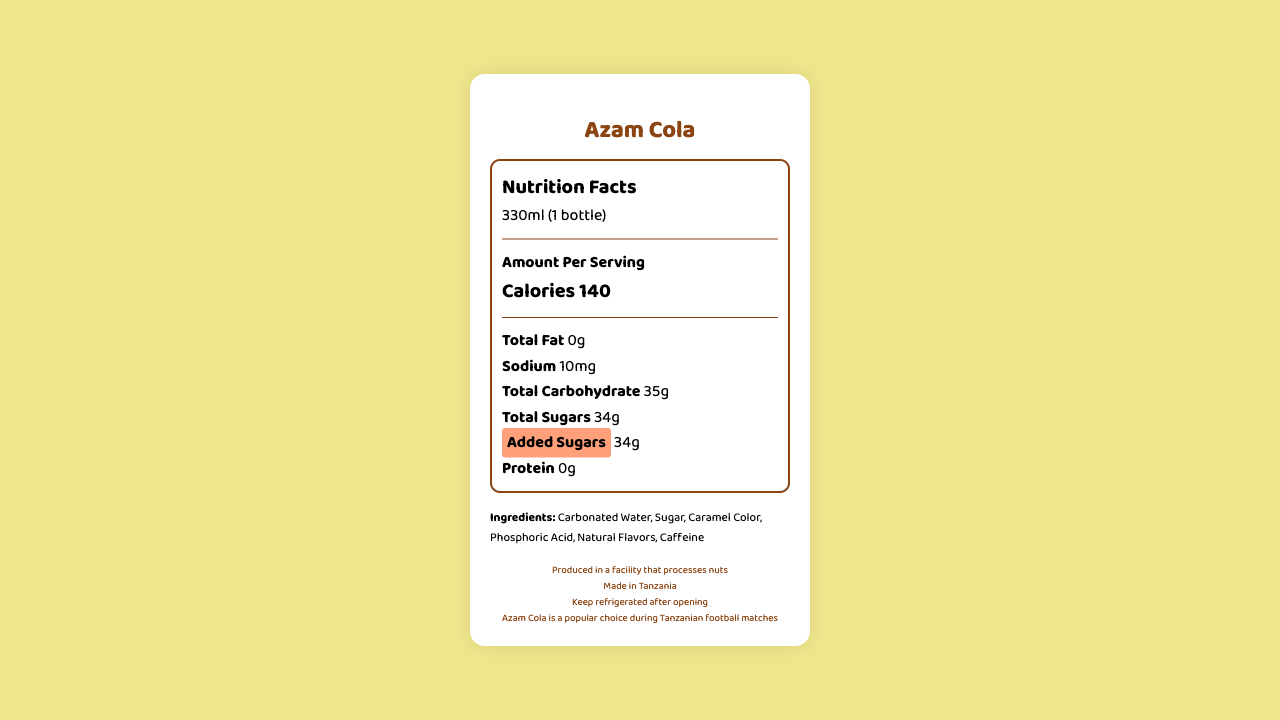What is the serving size of Azam Cola? The serving size is stated directly in the document as "330ml (1 bottle)."
Answer: 330ml (1 bottle) How many grams of total sugars are in one serving? The document lists "Total Sugars" as 34g per serving.
Answer: 34g Is there any protein in Azam Cola? The document shows "Protein: 0g," indicating that there is no protein in Azam Cola.
Answer: No Who is the manufacturer of Azam Cola? The document states that the manufacturer is Bakhresa Group.
Answer: Bakhresa Group What is the sodium content per serving? The document lists the sodium content as 10mg per serving.
Answer: 10mg Which ingredient is listed first in the ingredients list? The first ingredient listed in the document is "Carbonated Water."
Answer: Carbonated Water True or False: Azam Cola contains dietary fiber. The document lists "Dietary Fiber: 0g," indicating that it does not contain dietary fiber.
Answer: False How many calories are in Azam Cola per serving? A. 100 B. 120 C. 140 D. 160 The document states that there are 140 calories per serving of Azam Cola.
Answer: C What is the total carbohydrate content? A. 30g B. 35g C. 40g D. 45g The document lists the total carbohydrate content as 35g per serving.
Answer: B Which vitamin is present in Azam Cola? A. Vitamin A B. Vitamin C C. Vitamin D D. None The document indicates that vitamins A, C, and D are all listed as 0mg, so the correct answer is "None."
Answer: D Does the document provide any information about recycling? The document contains the statement "Please recycle" under the recycling information.
Answer: Yes Can you determine the expiration date of Azam Cola from the document? The document only mentions "Best before date printed on bottle," and does not provide an actual expiration date.
Answer: No Summarize the nutrition and additional information provided for Azam Cola. The explanation summarizes all the relevant nutritional information, ingredients, manufacturer, allergens, storage instructions, and recycling information as provided in the document.
Answer: Azam Cola contains 140 calories per 330ml serving. It has 0g of fat, cholesterol, dietary fiber, protein, and vitamins. It contains 10mg of sodium, 35g of total carbohydrates, including 34g of total and added sugars. Ingredients include carbonated water, sugar, caramel color, phosphoric acid, natural flavors, and caffeine. It is manufactured by Bakhresa Group and produced in a facility that processes nuts. Consumers are advised to keep it refrigerated after opening and to recycle the bottle. 